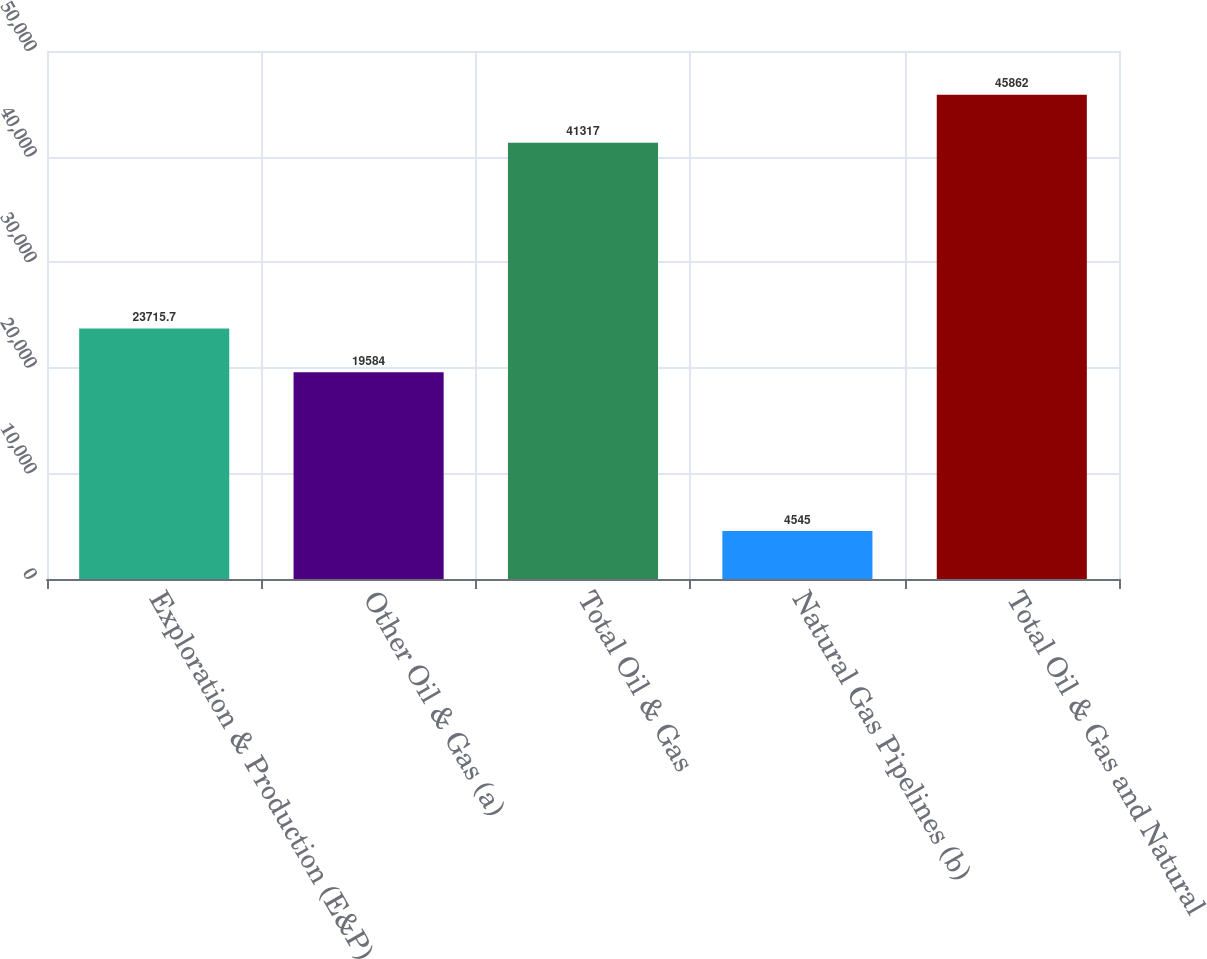Convert chart. <chart><loc_0><loc_0><loc_500><loc_500><bar_chart><fcel>Exploration & Production (E&P)<fcel>Other Oil & Gas (a)<fcel>Total Oil & Gas<fcel>Natural Gas Pipelines (b)<fcel>Total Oil & Gas and Natural<nl><fcel>23715.7<fcel>19584<fcel>41317<fcel>4545<fcel>45862<nl></chart> 